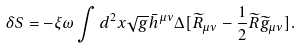Convert formula to latex. <formula><loc_0><loc_0><loc_500><loc_500>\delta S = - \xi \omega \int d ^ { 2 } x \sqrt { g } \bar { h } ^ { \mu \nu } \Delta [ \widetilde { R } _ { \mu \nu } - \frac { 1 } { 2 } \widetilde { R } \widetilde { g } _ { \mu \nu } ] .</formula> 